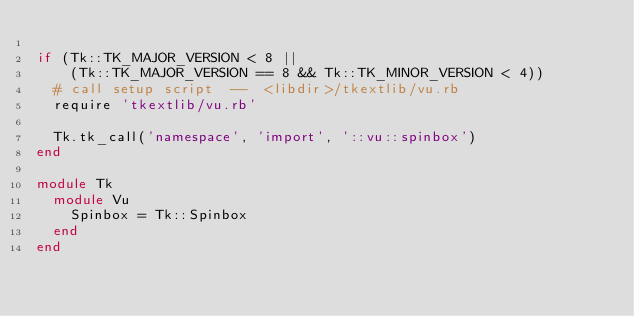<code> <loc_0><loc_0><loc_500><loc_500><_Ruby_>
if (Tk::TK_MAJOR_VERSION < 8 ||
    (Tk::TK_MAJOR_VERSION == 8 && Tk::TK_MINOR_VERSION < 4))
  # call setup script  --  <libdir>/tkextlib/vu.rb
  require 'tkextlib/vu.rb'

  Tk.tk_call('namespace', 'import', '::vu::spinbox')
end

module Tk
  module Vu
    Spinbox = Tk::Spinbox
  end
end
</code> 